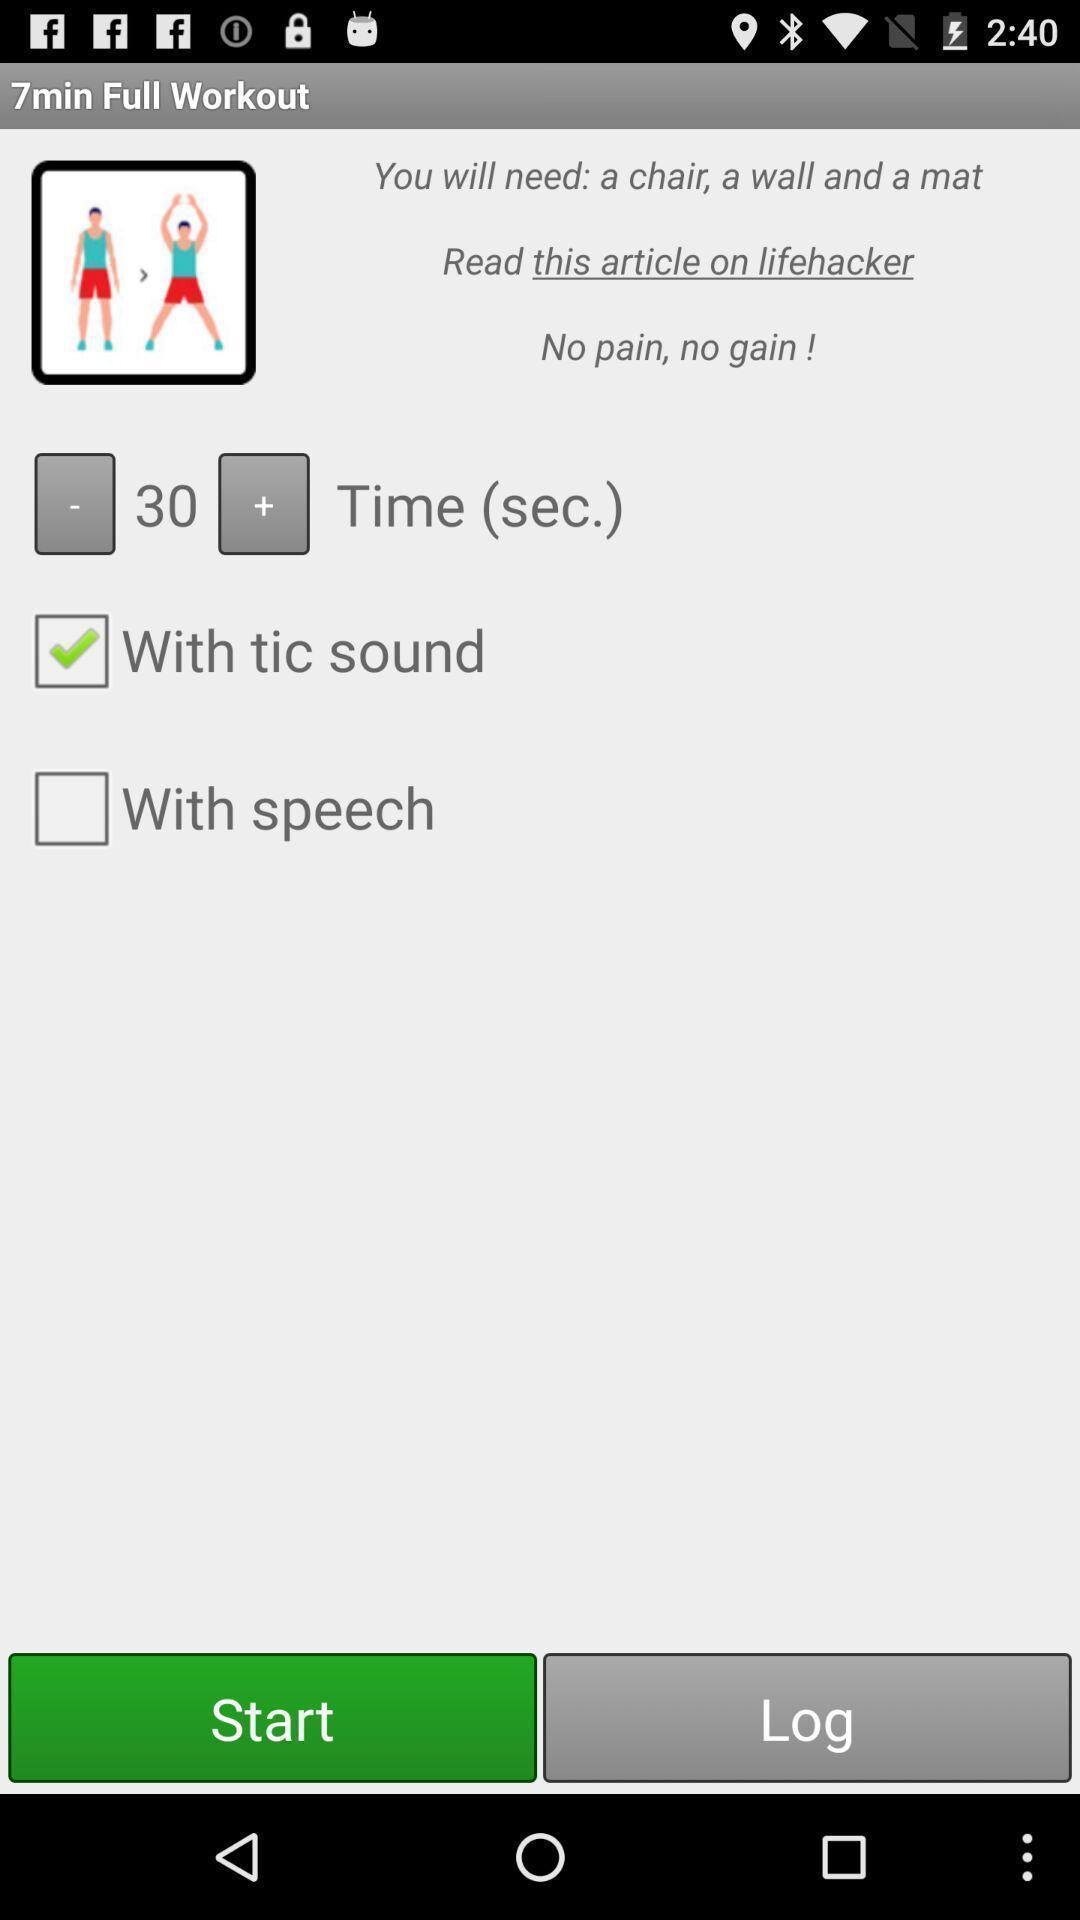Describe this image in words. Starting page of a fitness application. 